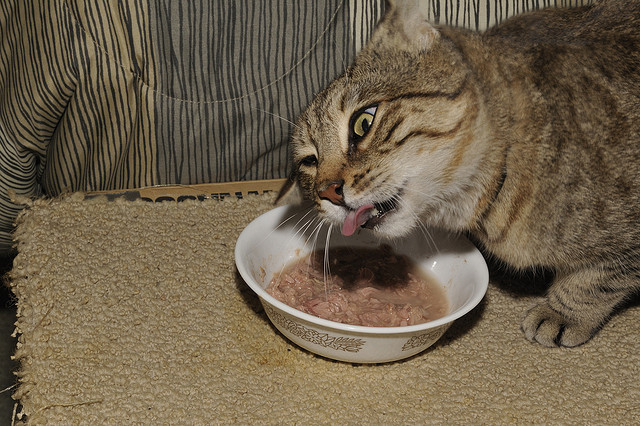Analyze the setting of the image. What does the decor and arrangement suggest about the household? The setting depicts a modest and homely environment featuring a fabric-upholstered couch or chair and a simple bowl for the cat. The visible patterns and textures suggest a comfortable living space that prioritizes practicality and the needs of its animal resident. The presence of household textiles and the choice of a simple feeding dish also hint at a no-frills approach towards domestic decor. 